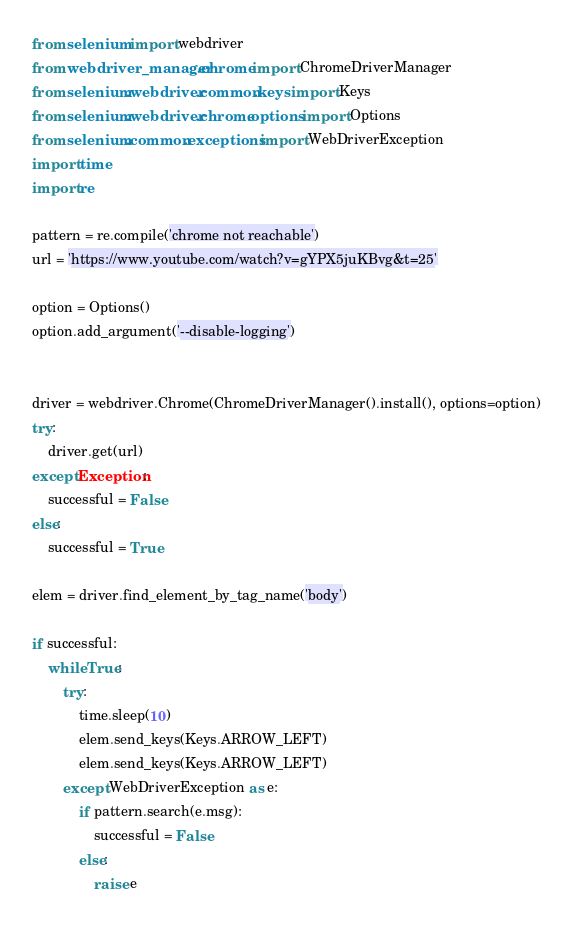<code> <loc_0><loc_0><loc_500><loc_500><_Python_>from selenium import webdriver
from webdriver_manager.chrome import ChromeDriverManager
from selenium.webdriver.common.keys import Keys
from selenium.webdriver.chrome.options import Options
from selenium.common.exceptions import WebDriverException
import time
import re

pattern = re.compile('chrome not reachable')
url = 'https://www.youtube.com/watch?v=gYPX5juKBvg&t=25'

option = Options()
option.add_argument('--disable-logging')


driver = webdriver.Chrome(ChromeDriverManager().install(), options=option)
try:
    driver.get(url)
except Exception:
    successful = False
else:
    successful = True

elem = driver.find_element_by_tag_name('body')

if successful:
    while True:
        try:
            time.sleep(10)
            elem.send_keys(Keys.ARROW_LEFT)
            elem.send_keys(Keys.ARROW_LEFT)
        except WebDriverException as e:
            if pattern.search(e.msg):
                successful = False
            else:
                raise e</code> 